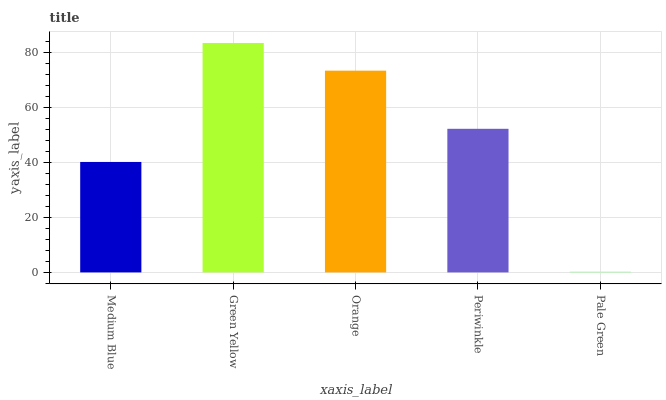Is Orange the minimum?
Answer yes or no. No. Is Orange the maximum?
Answer yes or no. No. Is Green Yellow greater than Orange?
Answer yes or no. Yes. Is Orange less than Green Yellow?
Answer yes or no. Yes. Is Orange greater than Green Yellow?
Answer yes or no. No. Is Green Yellow less than Orange?
Answer yes or no. No. Is Periwinkle the high median?
Answer yes or no. Yes. Is Periwinkle the low median?
Answer yes or no. Yes. Is Medium Blue the high median?
Answer yes or no. No. Is Pale Green the low median?
Answer yes or no. No. 